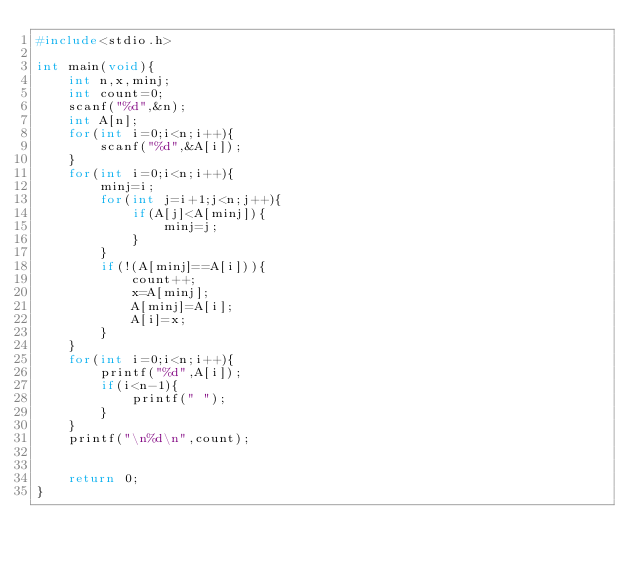Convert code to text. <code><loc_0><loc_0><loc_500><loc_500><_C_>#include<stdio.h>

int main(void){
    int n,x,minj;
    int count=0;
    scanf("%d",&n);
    int A[n];
    for(int i=0;i<n;i++){
        scanf("%d",&A[i]);
    }
    for(int i=0;i<n;i++){
        minj=i;
        for(int j=i+1;j<n;j++){
            if(A[j]<A[minj]){
                minj=j;
            }
        }
        if(!(A[minj]==A[i])){
            count++;
            x=A[minj];
            A[minj]=A[i];
            A[i]=x;
        }
    }
    for(int i=0;i<n;i++){
        printf("%d",A[i]);
        if(i<n-1){
            printf(" ");
        }
    }
    printf("\n%d\n",count);
    
    
    return 0;
}
</code> 